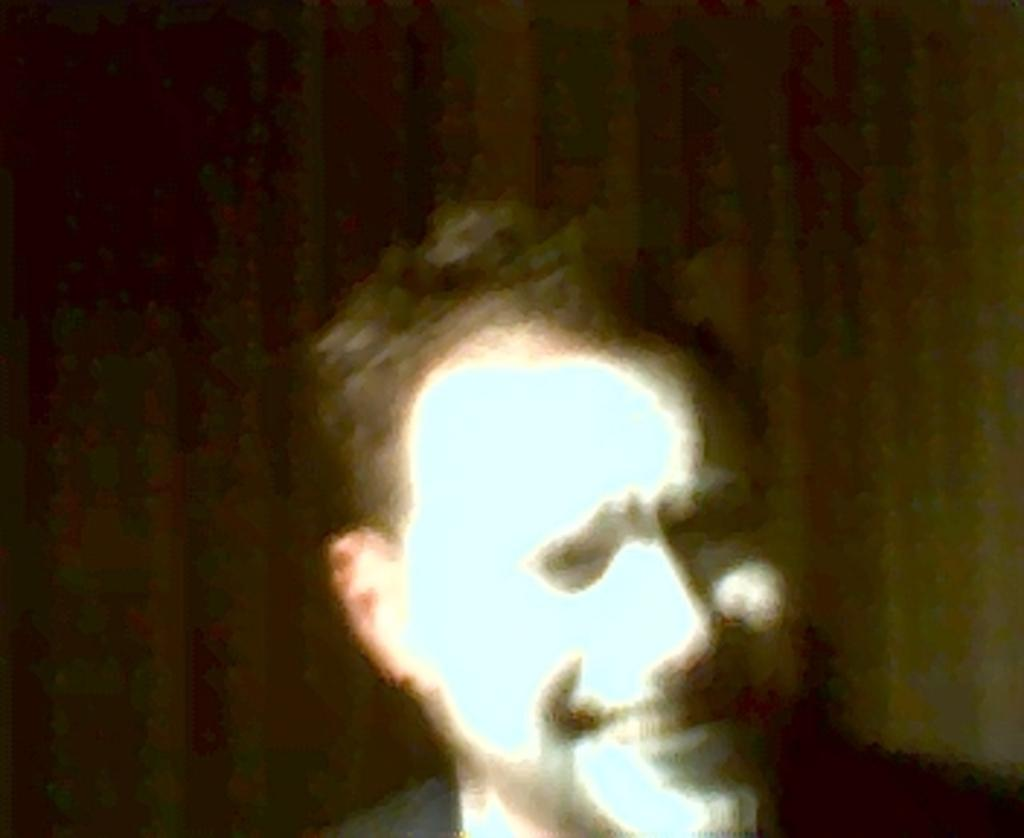What is the main subject of the image? There is a person in the image, but they are truncated towards the bottom. Can you describe the background of the image? The background of the image is dark. What type of button is being used to hold the quince in the image? There is no button or quince present in the image. What is the person in the image doing with the pot? There is no pot present in the image, and the person's actions cannot be determined based on the provided facts. 